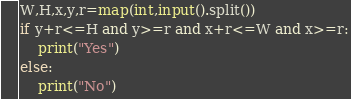Convert code to text. <code><loc_0><loc_0><loc_500><loc_500><_Python_>W,H,x,y,r=map(int,input().split())
if y+r<=H and y>=r and x+r<=W and x>=r:
    print("Yes")
else:
    print("No")
</code> 